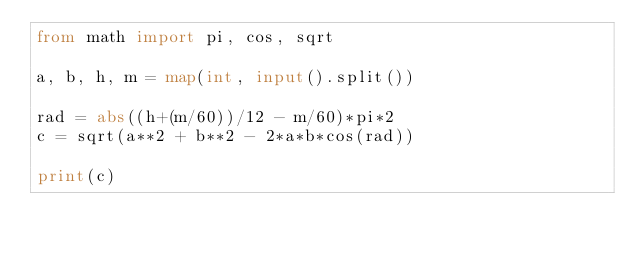<code> <loc_0><loc_0><loc_500><loc_500><_Python_>from math import pi, cos, sqrt

a, b, h, m = map(int, input().split())

rad = abs((h+(m/60))/12 - m/60)*pi*2
c = sqrt(a**2 + b**2 - 2*a*b*cos(rad))

print(c)</code> 